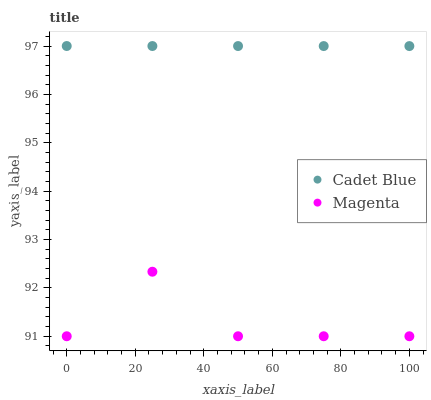Does Magenta have the minimum area under the curve?
Answer yes or no. Yes. Does Cadet Blue have the maximum area under the curve?
Answer yes or no. Yes. Does Cadet Blue have the minimum area under the curve?
Answer yes or no. No. Is Cadet Blue the smoothest?
Answer yes or no. Yes. Is Magenta the roughest?
Answer yes or no. Yes. Is Cadet Blue the roughest?
Answer yes or no. No. Does Magenta have the lowest value?
Answer yes or no. Yes. Does Cadet Blue have the lowest value?
Answer yes or no. No. Does Cadet Blue have the highest value?
Answer yes or no. Yes. Is Magenta less than Cadet Blue?
Answer yes or no. Yes. Is Cadet Blue greater than Magenta?
Answer yes or no. Yes. Does Magenta intersect Cadet Blue?
Answer yes or no. No. 